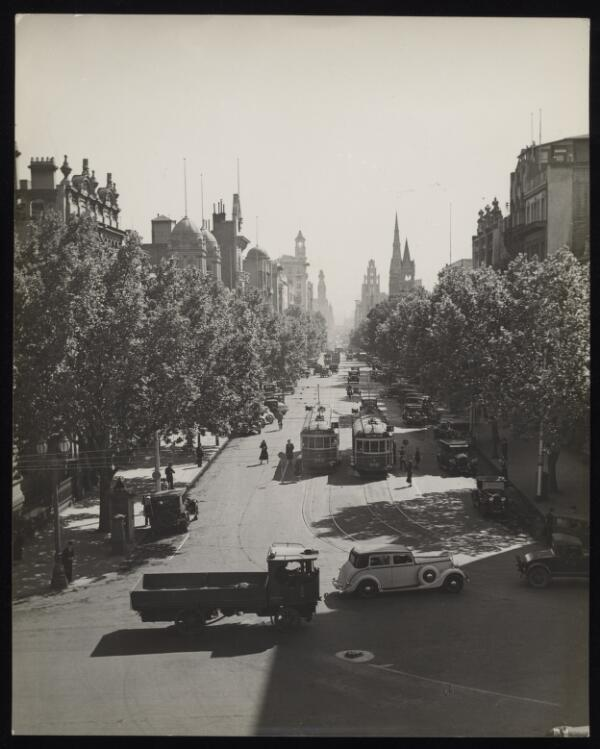Please describe the contents of this image in 5 or 6 sentences so that a person searching for it using text will be able to find it and your generated summary will provide them with an accurate description of the image. Only describe content present in the image. The black and white image depicts a bustling city street scene. The street is lined with tall trees that provide shade, and it is surrounded by a range of large, ornate buildings with various architectural styles. Several trams can be seen traveling down the center of the street, flanked by cars and trucks on either side. Pedestrians are walking along the sidewalks and crossing the street at various points. In the background, prominent clock towers and spires rise above the buildings, indicating a historical and possibly central area of the city. The overall atmosphere is busy and vibrant, capturing a moment of urban life. 